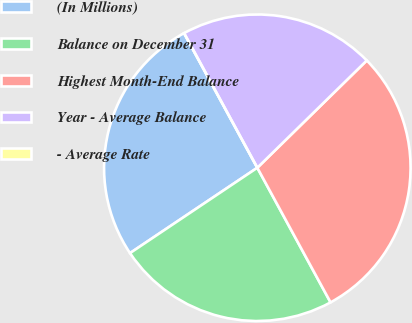Convert chart to OTSL. <chart><loc_0><loc_0><loc_500><loc_500><pie_chart><fcel>(In Millions)<fcel>Balance on December 31<fcel>Highest Month-End Balance<fcel>Year - Average Balance<fcel>- Average Rate<nl><fcel>26.47%<fcel>23.53%<fcel>29.41%<fcel>20.59%<fcel>0.0%<nl></chart> 